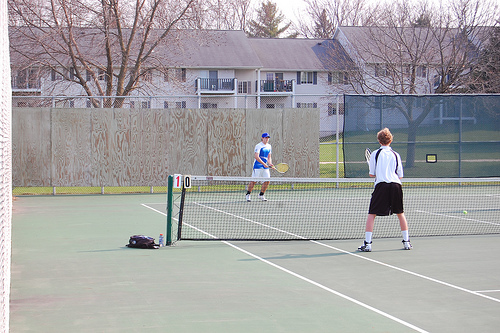How many people are in this photo? 2 